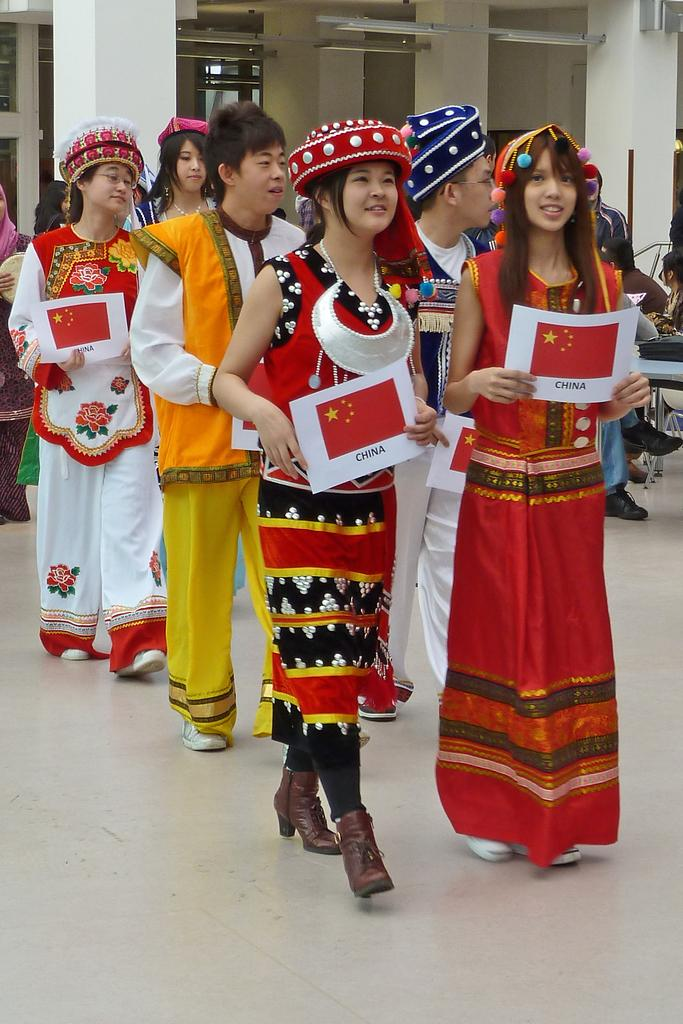What types of people are in the image? There are men and women in the image. What are the men and women wearing? The men and women are wearing traditional dress. What are the men and women holding in their hands? The men and women are holding red papers in their hands. What are the men and women doing in the image? The men and women are walking. What can be seen in the background of the image? There are white pillars and lights visible in the background. Can you see a mountain in the background of the image? There is no mountain visible in the background of the image. What type of lock is being used to secure the edge of the red papers? There is no lock present in the image, and the red papers are not secured with any lock. 